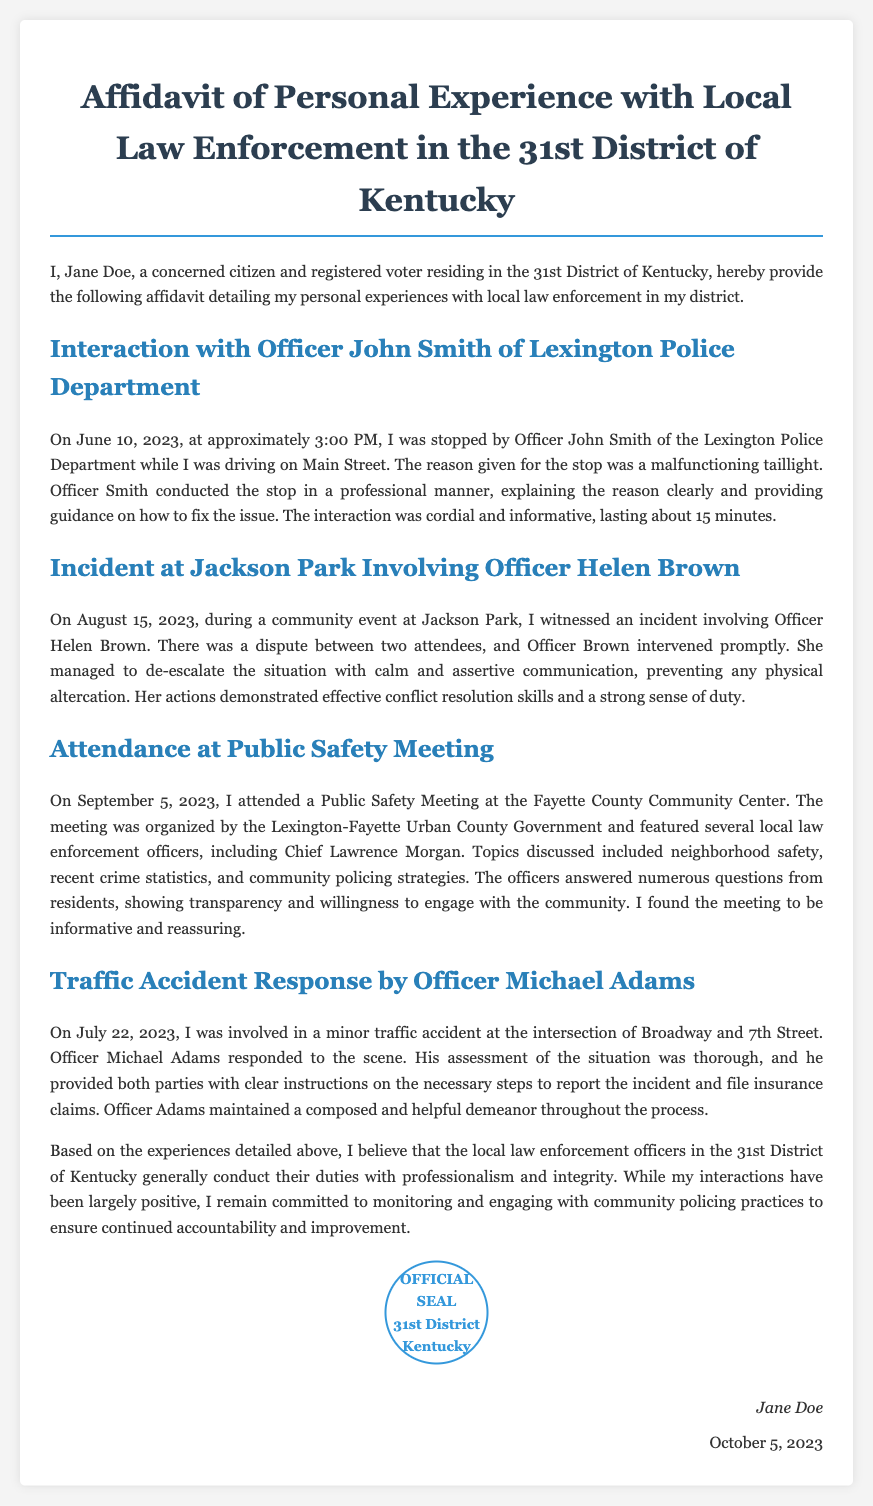What is the name of the affiant? The affiant is the individual providing the affidavit, which is Jane Doe.
Answer: Jane Doe When was the incident involving Officer Helen Brown? The date of the incident with Officer Helen Brown is stated as August 15, 2023.
Answer: August 15, 2023 What was the reason for the traffic stop by Officer John Smith? The reason for the traffic stop was a malfunctioning taillight.
Answer: Malfunctioning taillight How long did the interaction with Officer John Smith last? The interaction with Officer John Smith lasted about 15 minutes.
Answer: 15 minutes Which event did the affiant attend on September 5, 2023? The affiant attended a Public Safety Meeting organized by the Lexington-Fayette Urban County Government.
Answer: Public Safety Meeting What skills did Officer Helen Brown demonstrate during the incident at Jackson Park? Officer Helen Brown demonstrated effective conflict resolution skills during the incident.
Answer: Conflict resolution skills Who responded to the minor traffic accident involving the affiant? The officer who responded to the minor traffic accident was Officer Michael Adams.
Answer: Officer Michael Adams What is one of the main topics discussed at the Public Safety Meeting? One of the main topics discussed at the meeting included neighborhood safety.
Answer: Neighborhood safety 